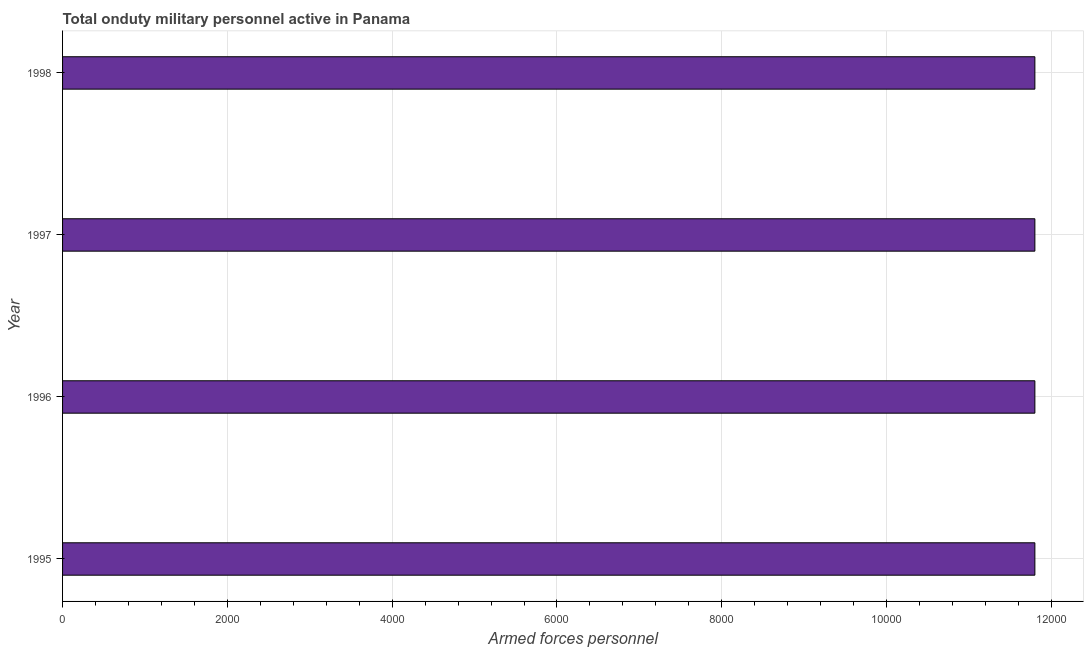Does the graph contain any zero values?
Provide a short and direct response. No. Does the graph contain grids?
Offer a terse response. Yes. What is the title of the graph?
Offer a very short reply. Total onduty military personnel active in Panama. What is the label or title of the X-axis?
Provide a short and direct response. Armed forces personnel. What is the label or title of the Y-axis?
Keep it short and to the point. Year. What is the number of armed forces personnel in 1998?
Give a very brief answer. 1.18e+04. Across all years, what is the maximum number of armed forces personnel?
Offer a terse response. 1.18e+04. Across all years, what is the minimum number of armed forces personnel?
Your answer should be compact. 1.18e+04. What is the sum of the number of armed forces personnel?
Keep it short and to the point. 4.72e+04. What is the average number of armed forces personnel per year?
Provide a succinct answer. 1.18e+04. What is the median number of armed forces personnel?
Ensure brevity in your answer.  1.18e+04. What is the ratio of the number of armed forces personnel in 1997 to that in 1998?
Your answer should be compact. 1. Is the number of armed forces personnel in 1995 less than that in 1996?
Provide a short and direct response. No. Is the difference between the number of armed forces personnel in 1996 and 1997 greater than the difference between any two years?
Offer a very short reply. Yes. In how many years, is the number of armed forces personnel greater than the average number of armed forces personnel taken over all years?
Your answer should be very brief. 0. How many bars are there?
Give a very brief answer. 4. Are the values on the major ticks of X-axis written in scientific E-notation?
Ensure brevity in your answer.  No. What is the Armed forces personnel of 1995?
Provide a succinct answer. 1.18e+04. What is the Armed forces personnel of 1996?
Your answer should be very brief. 1.18e+04. What is the Armed forces personnel in 1997?
Offer a terse response. 1.18e+04. What is the Armed forces personnel of 1998?
Your response must be concise. 1.18e+04. What is the difference between the Armed forces personnel in 1995 and 1996?
Offer a very short reply. 0. What is the difference between the Armed forces personnel in 1995 and 1998?
Give a very brief answer. 0. What is the difference between the Armed forces personnel in 1996 and 1998?
Offer a terse response. 0. What is the ratio of the Armed forces personnel in 1995 to that in 1997?
Provide a short and direct response. 1. What is the ratio of the Armed forces personnel in 1995 to that in 1998?
Ensure brevity in your answer.  1. What is the ratio of the Armed forces personnel in 1996 to that in 1998?
Give a very brief answer. 1. What is the ratio of the Armed forces personnel in 1997 to that in 1998?
Offer a very short reply. 1. 